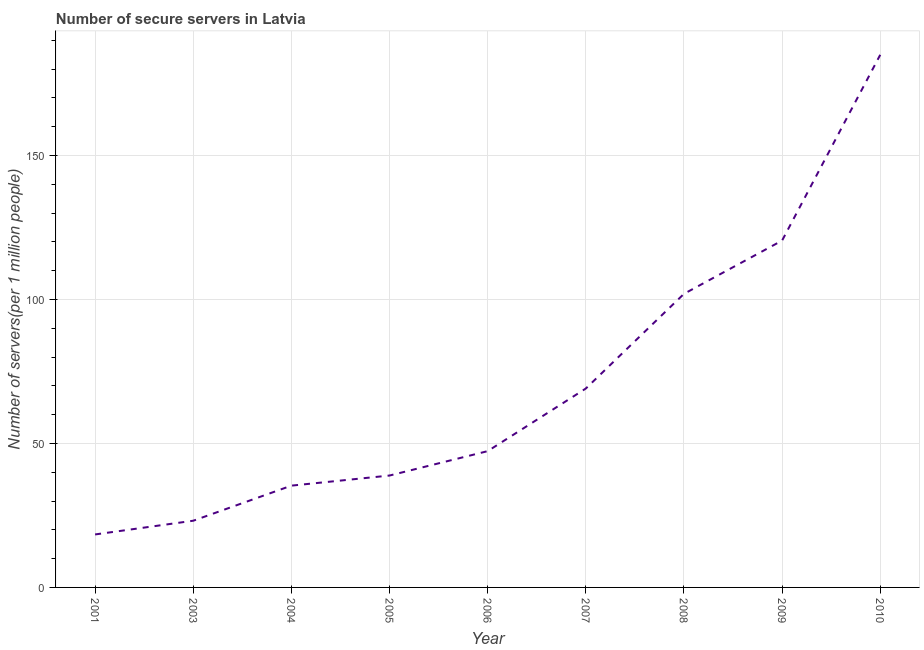What is the number of secure internet servers in 2001?
Offer a terse response. 18.4. Across all years, what is the maximum number of secure internet servers?
Offer a very short reply. 184.98. Across all years, what is the minimum number of secure internet servers?
Your response must be concise. 18.4. In which year was the number of secure internet servers maximum?
Provide a succinct answer. 2010. In which year was the number of secure internet servers minimum?
Provide a short and direct response. 2001. What is the sum of the number of secure internet servers?
Make the answer very short. 639.59. What is the difference between the number of secure internet servers in 2001 and 2004?
Keep it short and to the point. -16.95. What is the average number of secure internet servers per year?
Ensure brevity in your answer.  71.07. What is the median number of secure internet servers?
Your answer should be very brief. 47.33. In how many years, is the number of secure internet servers greater than 40 ?
Offer a very short reply. 5. What is the ratio of the number of secure internet servers in 2005 to that in 2009?
Provide a succinct answer. 0.32. Is the number of secure internet servers in 2005 less than that in 2010?
Give a very brief answer. Yes. What is the difference between the highest and the second highest number of secure internet servers?
Your answer should be very brief. 64.51. Is the sum of the number of secure internet servers in 2008 and 2010 greater than the maximum number of secure internet servers across all years?
Make the answer very short. Yes. What is the difference between the highest and the lowest number of secure internet servers?
Your response must be concise. 166.58. How many lines are there?
Your answer should be very brief. 1. Are the values on the major ticks of Y-axis written in scientific E-notation?
Keep it short and to the point. No. Does the graph contain any zero values?
Ensure brevity in your answer.  No. What is the title of the graph?
Your answer should be compact. Number of secure servers in Latvia. What is the label or title of the X-axis?
Your answer should be very brief. Year. What is the label or title of the Y-axis?
Make the answer very short. Number of servers(per 1 million people). What is the Number of servers(per 1 million people) in 2001?
Provide a succinct answer. 18.4. What is the Number of servers(per 1 million people) of 2003?
Your response must be concise. 23.16. What is the Number of servers(per 1 million people) of 2004?
Make the answer very short. 35.35. What is the Number of servers(per 1 million people) of 2005?
Offer a terse response. 38.86. What is the Number of servers(per 1 million people) in 2006?
Your response must be concise. 47.33. What is the Number of servers(per 1 million people) in 2007?
Your response must be concise. 69.08. What is the Number of servers(per 1 million people) of 2008?
Provide a short and direct response. 101.96. What is the Number of servers(per 1 million people) in 2009?
Give a very brief answer. 120.47. What is the Number of servers(per 1 million people) in 2010?
Give a very brief answer. 184.98. What is the difference between the Number of servers(per 1 million people) in 2001 and 2003?
Your answer should be compact. -4.77. What is the difference between the Number of servers(per 1 million people) in 2001 and 2004?
Provide a short and direct response. -16.95. What is the difference between the Number of servers(per 1 million people) in 2001 and 2005?
Provide a short and direct response. -20.46. What is the difference between the Number of servers(per 1 million people) in 2001 and 2006?
Provide a succinct answer. -28.93. What is the difference between the Number of servers(per 1 million people) in 2001 and 2007?
Ensure brevity in your answer.  -50.68. What is the difference between the Number of servers(per 1 million people) in 2001 and 2008?
Your answer should be compact. -83.56. What is the difference between the Number of servers(per 1 million people) in 2001 and 2009?
Ensure brevity in your answer.  -102.07. What is the difference between the Number of servers(per 1 million people) in 2001 and 2010?
Your answer should be very brief. -166.58. What is the difference between the Number of servers(per 1 million people) in 2003 and 2004?
Give a very brief answer. -12.18. What is the difference between the Number of servers(per 1 million people) in 2003 and 2005?
Your answer should be compact. -15.7. What is the difference between the Number of servers(per 1 million people) in 2003 and 2006?
Provide a short and direct response. -24.17. What is the difference between the Number of servers(per 1 million people) in 2003 and 2007?
Your answer should be compact. -45.92. What is the difference between the Number of servers(per 1 million people) in 2003 and 2008?
Offer a terse response. -78.8. What is the difference between the Number of servers(per 1 million people) in 2003 and 2009?
Your response must be concise. -97.3. What is the difference between the Number of servers(per 1 million people) in 2003 and 2010?
Provide a short and direct response. -161.81. What is the difference between the Number of servers(per 1 million people) in 2004 and 2005?
Your answer should be very brief. -3.51. What is the difference between the Number of servers(per 1 million people) in 2004 and 2006?
Offer a very short reply. -11.98. What is the difference between the Number of servers(per 1 million people) in 2004 and 2007?
Your response must be concise. -33.73. What is the difference between the Number of servers(per 1 million people) in 2004 and 2008?
Provide a succinct answer. -66.61. What is the difference between the Number of servers(per 1 million people) in 2004 and 2009?
Ensure brevity in your answer.  -85.12. What is the difference between the Number of servers(per 1 million people) in 2004 and 2010?
Your answer should be very brief. -149.63. What is the difference between the Number of servers(per 1 million people) in 2005 and 2006?
Keep it short and to the point. -8.47. What is the difference between the Number of servers(per 1 million people) in 2005 and 2007?
Provide a short and direct response. -30.22. What is the difference between the Number of servers(per 1 million people) in 2005 and 2008?
Provide a short and direct response. -63.1. What is the difference between the Number of servers(per 1 million people) in 2005 and 2009?
Give a very brief answer. -81.61. What is the difference between the Number of servers(per 1 million people) in 2005 and 2010?
Your answer should be very brief. -146.12. What is the difference between the Number of servers(per 1 million people) in 2006 and 2007?
Your response must be concise. -21.75. What is the difference between the Number of servers(per 1 million people) in 2006 and 2008?
Make the answer very short. -54.63. What is the difference between the Number of servers(per 1 million people) in 2006 and 2009?
Your answer should be very brief. -73.13. What is the difference between the Number of servers(per 1 million people) in 2006 and 2010?
Your answer should be very brief. -137.64. What is the difference between the Number of servers(per 1 million people) in 2007 and 2008?
Your answer should be compact. -32.88. What is the difference between the Number of servers(per 1 million people) in 2007 and 2009?
Ensure brevity in your answer.  -51.39. What is the difference between the Number of servers(per 1 million people) in 2007 and 2010?
Your answer should be very brief. -115.9. What is the difference between the Number of servers(per 1 million people) in 2008 and 2009?
Your answer should be very brief. -18.51. What is the difference between the Number of servers(per 1 million people) in 2008 and 2010?
Give a very brief answer. -83.02. What is the difference between the Number of servers(per 1 million people) in 2009 and 2010?
Provide a short and direct response. -64.51. What is the ratio of the Number of servers(per 1 million people) in 2001 to that in 2003?
Give a very brief answer. 0.79. What is the ratio of the Number of servers(per 1 million people) in 2001 to that in 2004?
Offer a very short reply. 0.52. What is the ratio of the Number of servers(per 1 million people) in 2001 to that in 2005?
Ensure brevity in your answer.  0.47. What is the ratio of the Number of servers(per 1 million people) in 2001 to that in 2006?
Ensure brevity in your answer.  0.39. What is the ratio of the Number of servers(per 1 million people) in 2001 to that in 2007?
Provide a short and direct response. 0.27. What is the ratio of the Number of servers(per 1 million people) in 2001 to that in 2008?
Your response must be concise. 0.18. What is the ratio of the Number of servers(per 1 million people) in 2001 to that in 2009?
Give a very brief answer. 0.15. What is the ratio of the Number of servers(per 1 million people) in 2001 to that in 2010?
Offer a terse response. 0.1. What is the ratio of the Number of servers(per 1 million people) in 2003 to that in 2004?
Provide a short and direct response. 0.66. What is the ratio of the Number of servers(per 1 million people) in 2003 to that in 2005?
Make the answer very short. 0.6. What is the ratio of the Number of servers(per 1 million people) in 2003 to that in 2006?
Make the answer very short. 0.49. What is the ratio of the Number of servers(per 1 million people) in 2003 to that in 2007?
Your answer should be compact. 0.34. What is the ratio of the Number of servers(per 1 million people) in 2003 to that in 2008?
Make the answer very short. 0.23. What is the ratio of the Number of servers(per 1 million people) in 2003 to that in 2009?
Keep it short and to the point. 0.19. What is the ratio of the Number of servers(per 1 million people) in 2003 to that in 2010?
Provide a short and direct response. 0.12. What is the ratio of the Number of servers(per 1 million people) in 2004 to that in 2005?
Provide a succinct answer. 0.91. What is the ratio of the Number of servers(per 1 million people) in 2004 to that in 2006?
Offer a terse response. 0.75. What is the ratio of the Number of servers(per 1 million people) in 2004 to that in 2007?
Provide a succinct answer. 0.51. What is the ratio of the Number of servers(per 1 million people) in 2004 to that in 2008?
Ensure brevity in your answer.  0.35. What is the ratio of the Number of servers(per 1 million people) in 2004 to that in 2009?
Provide a short and direct response. 0.29. What is the ratio of the Number of servers(per 1 million people) in 2004 to that in 2010?
Make the answer very short. 0.19. What is the ratio of the Number of servers(per 1 million people) in 2005 to that in 2006?
Your answer should be very brief. 0.82. What is the ratio of the Number of servers(per 1 million people) in 2005 to that in 2007?
Give a very brief answer. 0.56. What is the ratio of the Number of servers(per 1 million people) in 2005 to that in 2008?
Your answer should be very brief. 0.38. What is the ratio of the Number of servers(per 1 million people) in 2005 to that in 2009?
Give a very brief answer. 0.32. What is the ratio of the Number of servers(per 1 million people) in 2005 to that in 2010?
Your answer should be very brief. 0.21. What is the ratio of the Number of servers(per 1 million people) in 2006 to that in 2007?
Provide a succinct answer. 0.69. What is the ratio of the Number of servers(per 1 million people) in 2006 to that in 2008?
Offer a very short reply. 0.46. What is the ratio of the Number of servers(per 1 million people) in 2006 to that in 2009?
Provide a short and direct response. 0.39. What is the ratio of the Number of servers(per 1 million people) in 2006 to that in 2010?
Offer a very short reply. 0.26. What is the ratio of the Number of servers(per 1 million people) in 2007 to that in 2008?
Your response must be concise. 0.68. What is the ratio of the Number of servers(per 1 million people) in 2007 to that in 2009?
Keep it short and to the point. 0.57. What is the ratio of the Number of servers(per 1 million people) in 2007 to that in 2010?
Keep it short and to the point. 0.37. What is the ratio of the Number of servers(per 1 million people) in 2008 to that in 2009?
Your response must be concise. 0.85. What is the ratio of the Number of servers(per 1 million people) in 2008 to that in 2010?
Make the answer very short. 0.55. What is the ratio of the Number of servers(per 1 million people) in 2009 to that in 2010?
Provide a succinct answer. 0.65. 